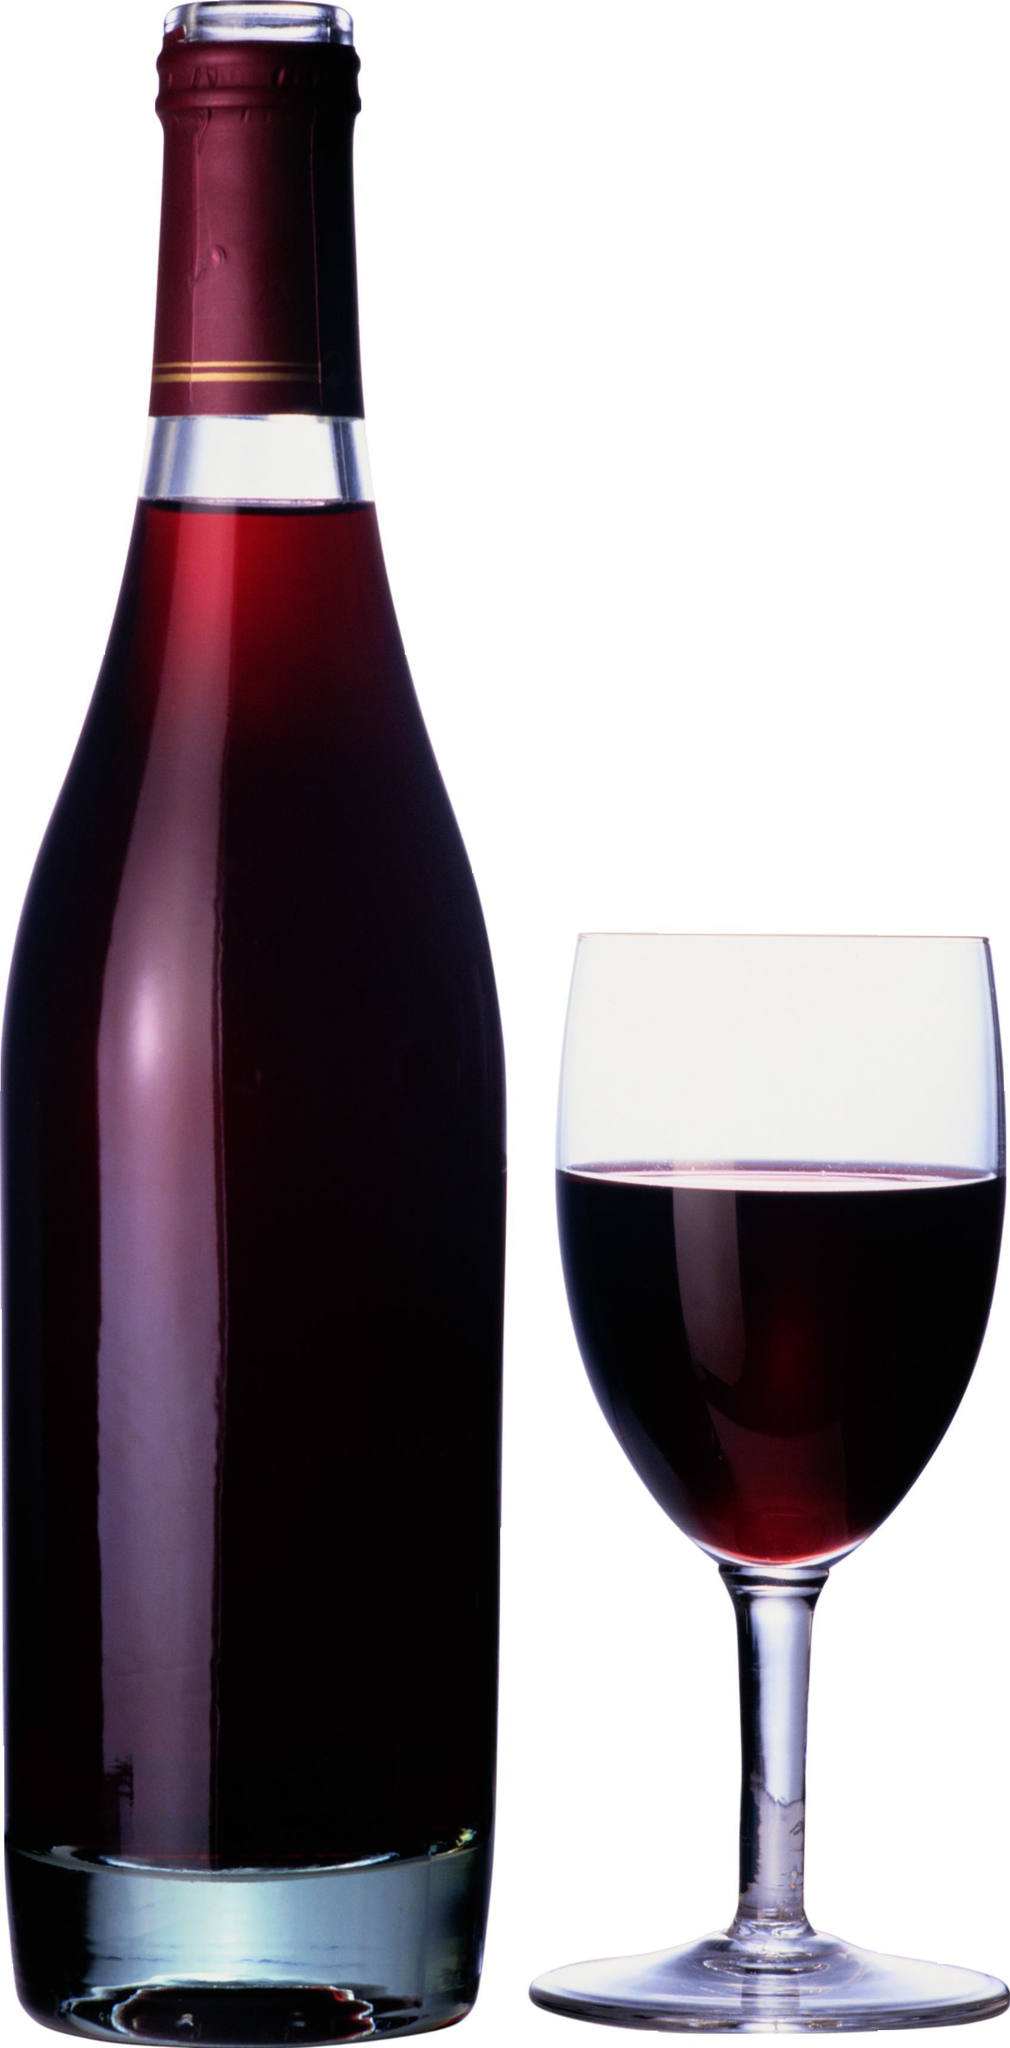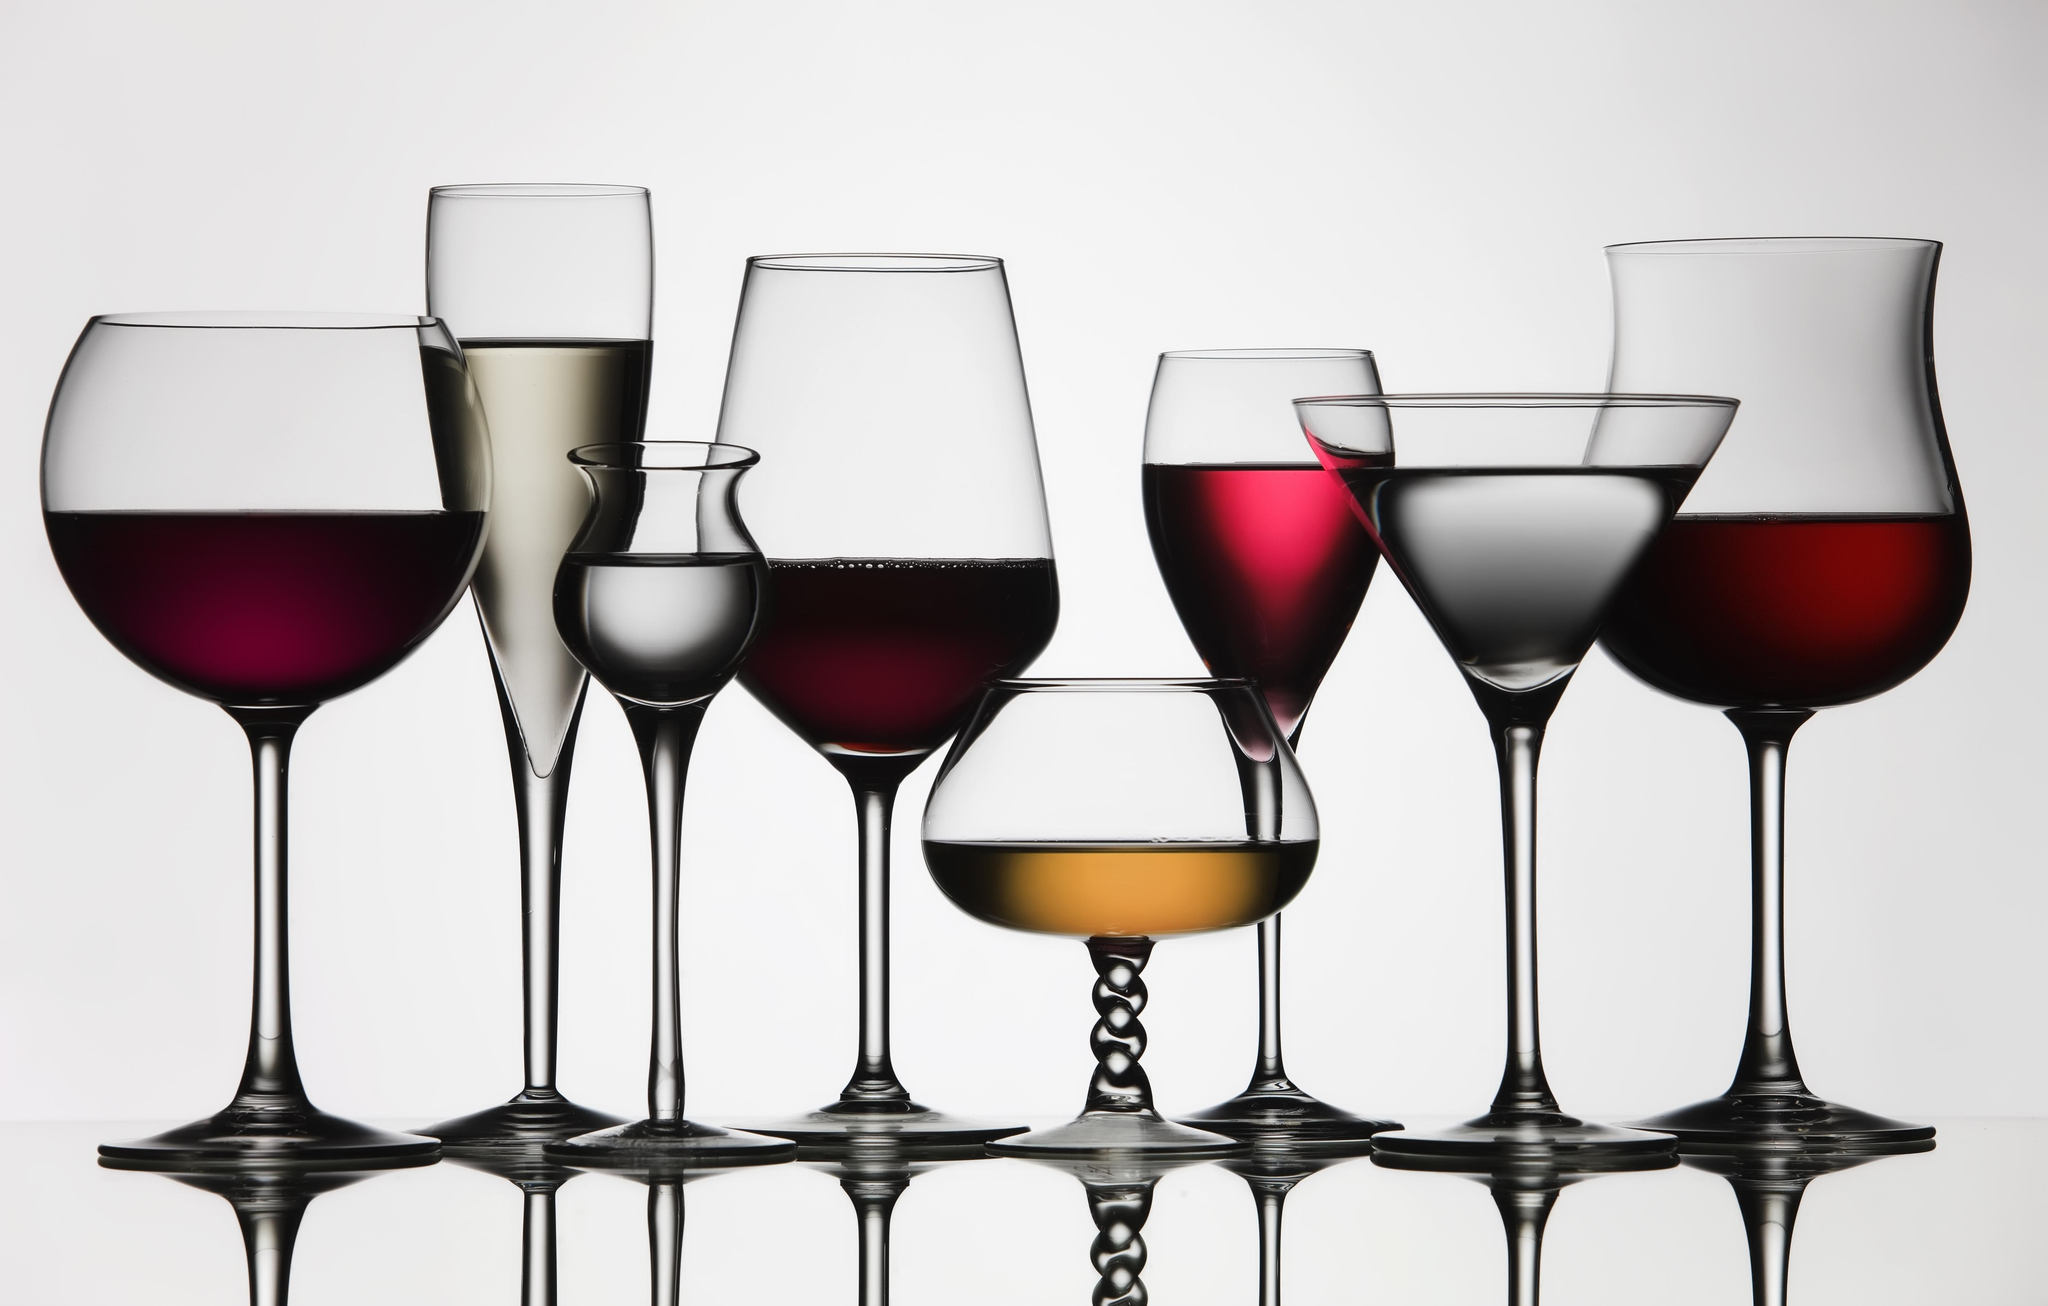The first image is the image on the left, the second image is the image on the right. For the images displayed, is the sentence "the image on the left has a wine glass next to the bottle" factually correct? Answer yes or no. Yes. The first image is the image on the left, the second image is the image on the right. Analyze the images presented: Is the assertion "One of the images has exactly three partially filled glasses." valid? Answer yes or no. No. 